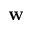Convert formula to latex. <formula><loc_0><loc_0><loc_500><loc_500>w</formula> 